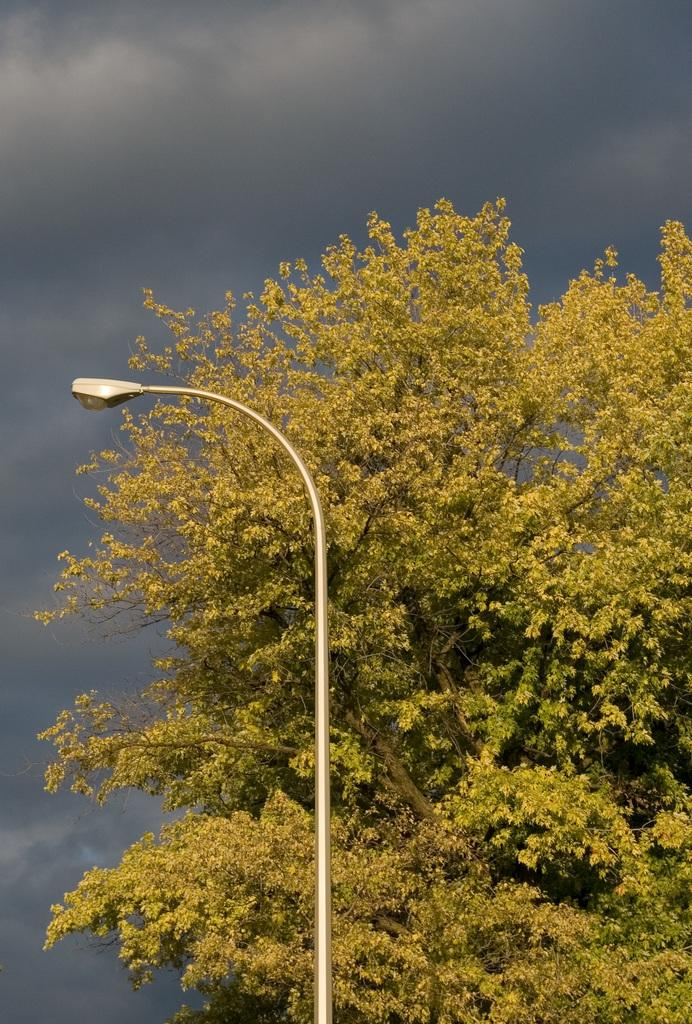What type of plant can be seen in the image? There is a tree in the image. What structure is also present in the image? There is a light pole in the image. What can be seen in the distance in the image? The sky is visible in the background of the image. How many eyes can be seen on the tree in the image? There are no eyes present on the tree in the image, as trees are plants and do not have eyes. 